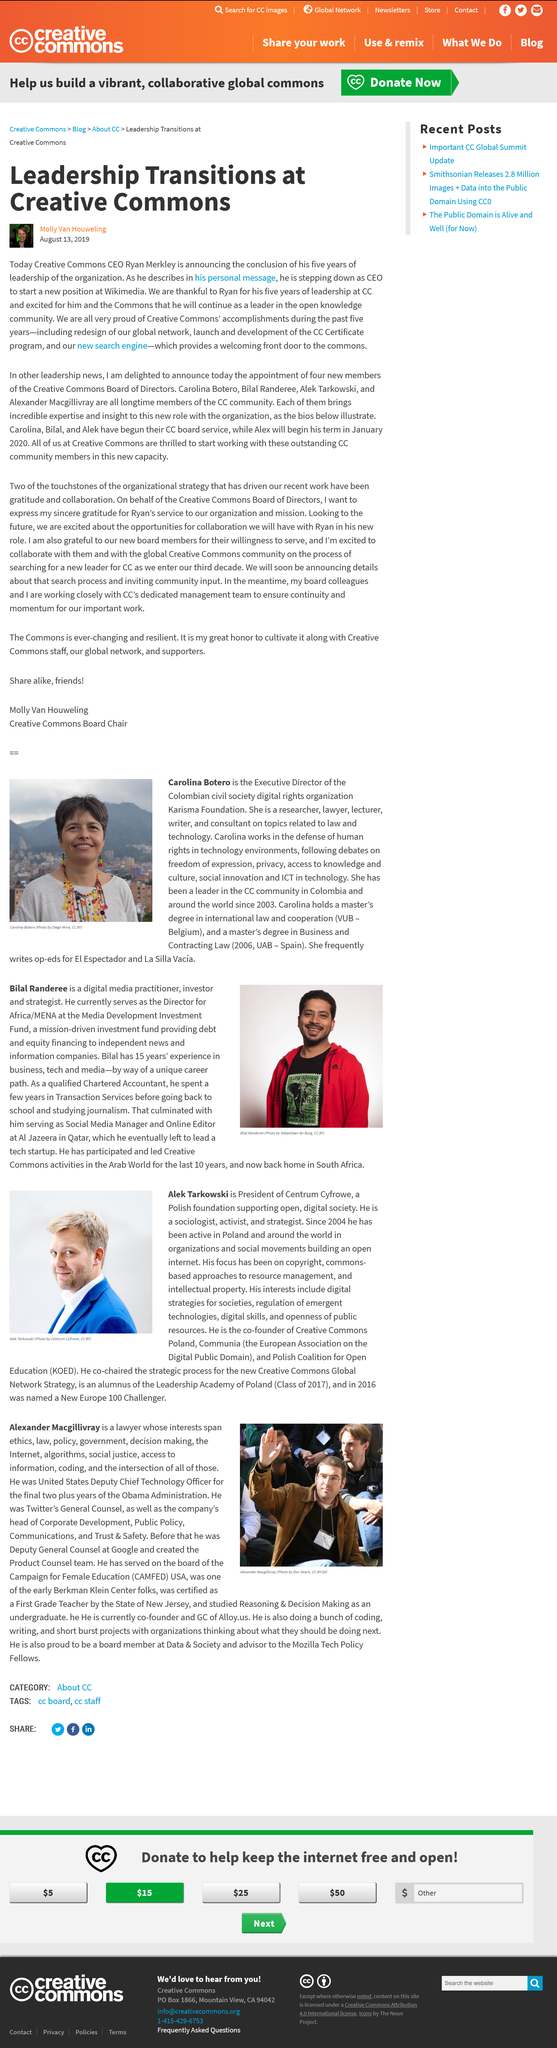Highlight a few significant elements in this photo. Carolina Botero is the Executive Director of the Karisma Foundation, a Colombian civil society organization dedicated to promoting digital rights. The Polish Coalition for Open Education, known as KOED, is dedicated to promoting the use and benefits of open educational resources in Poland and beyond. Ryan Merkley's conclusion as CEO was announced on August 13, 2019. Carolina Botero received a Master's degree in Business and Contracting Law in the year 2006. In the year 2016, Tarkowski was named a New Europe 100 Challenger. 